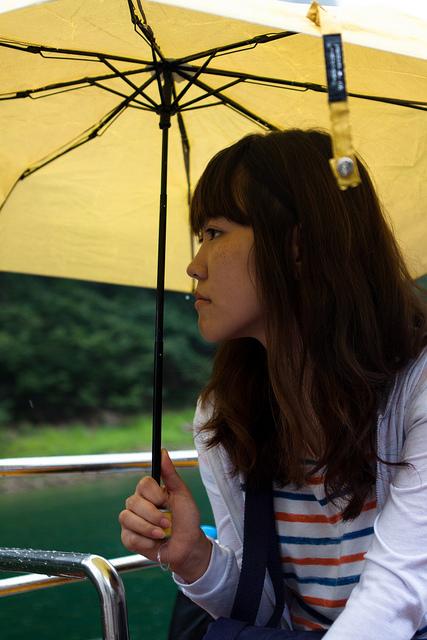Is this girl happy?
Write a very short answer. No. Does she look sad?
Be succinct. Yes. What is the pattern on her shirt?
Be succinct. Stripes. What is she looking over?
Concise answer only. Railing. 